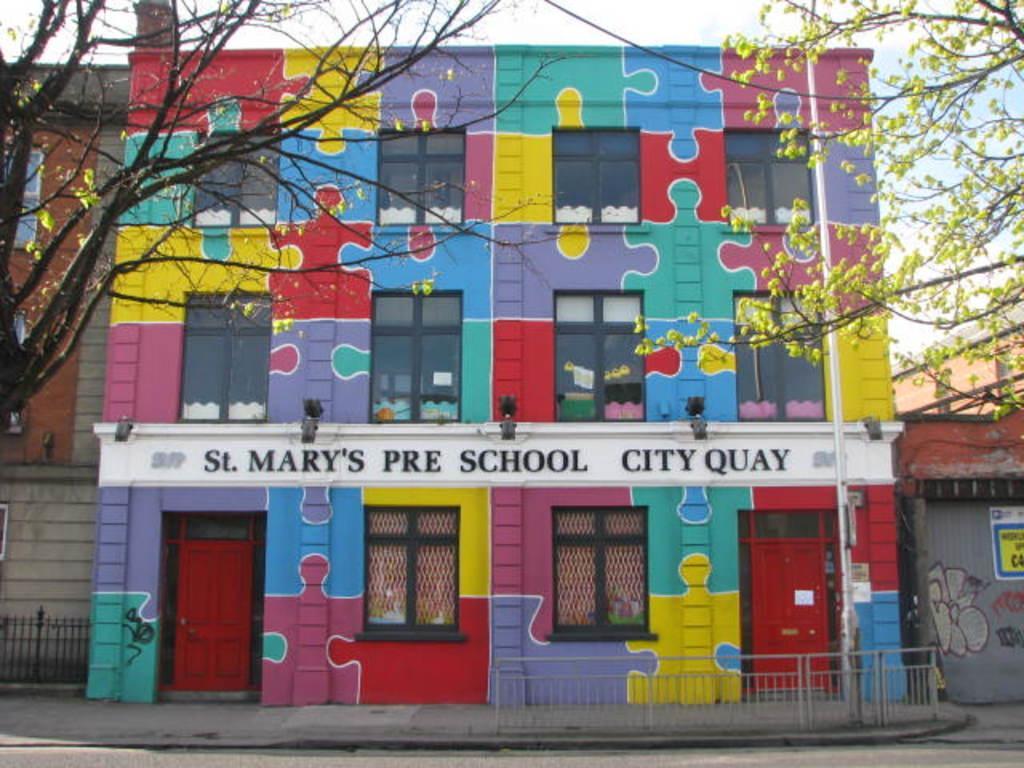Please provide a concise description of this image. In this image in the background there are buildings and in the front there are trees. In the center there is a fence and on the building there is a painting and there is some text written on the wall of the building. 